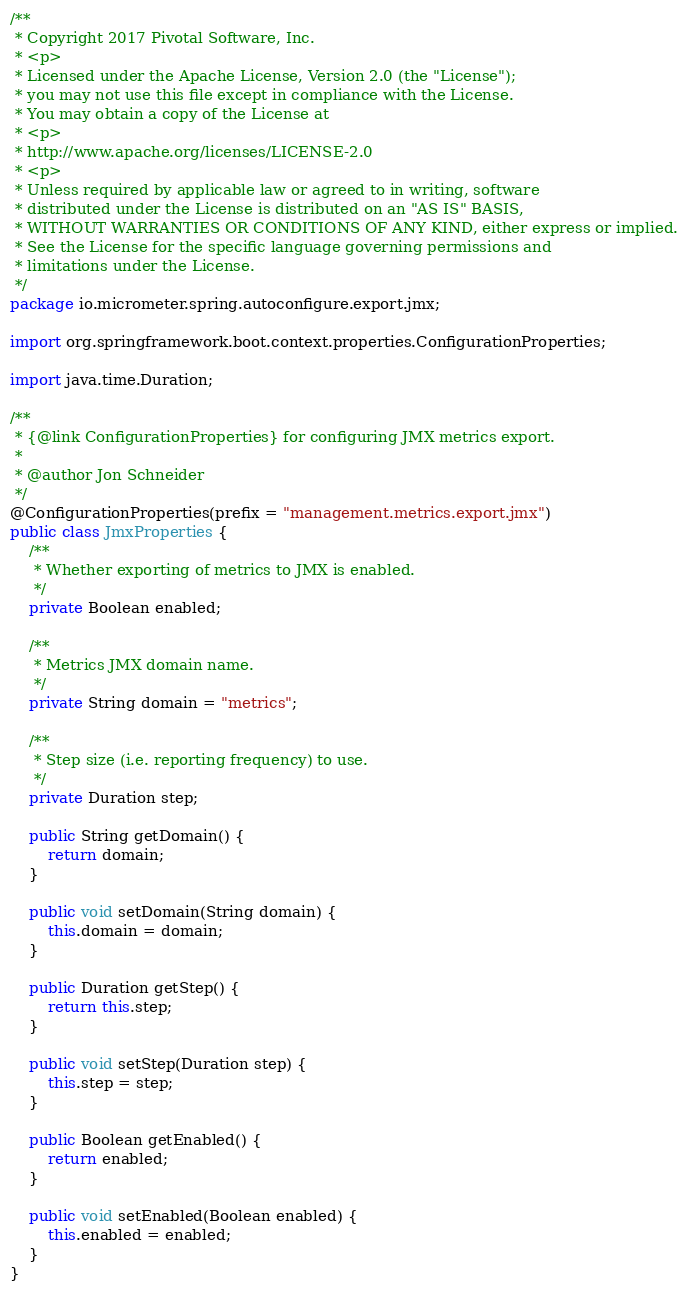Convert code to text. <code><loc_0><loc_0><loc_500><loc_500><_Java_>/**
 * Copyright 2017 Pivotal Software, Inc.
 * <p>
 * Licensed under the Apache License, Version 2.0 (the "License");
 * you may not use this file except in compliance with the License.
 * You may obtain a copy of the License at
 * <p>
 * http://www.apache.org/licenses/LICENSE-2.0
 * <p>
 * Unless required by applicable law or agreed to in writing, software
 * distributed under the License is distributed on an "AS IS" BASIS,
 * WITHOUT WARRANTIES OR CONDITIONS OF ANY KIND, either express or implied.
 * See the License for the specific language governing permissions and
 * limitations under the License.
 */
package io.micrometer.spring.autoconfigure.export.jmx;

import org.springframework.boot.context.properties.ConfigurationProperties;

import java.time.Duration;

/**
 * {@link ConfigurationProperties} for configuring JMX metrics export.
 *
 * @author Jon Schneider
 */
@ConfigurationProperties(prefix = "management.metrics.export.jmx")
public class JmxProperties {
    /**
     * Whether exporting of metrics to JMX is enabled.
     */
    private Boolean enabled;

    /**
     * Metrics JMX domain name.
     */
    private String domain = "metrics";

    /**
     * Step size (i.e. reporting frequency) to use.
     */
    private Duration step;

    public String getDomain() {
        return domain;
    }

    public void setDomain(String domain) {
        this.domain = domain;
    }

    public Duration getStep() {
        return this.step;
    }

    public void setStep(Duration step) {
        this.step = step;
    }

    public Boolean getEnabled() {
        return enabled;
    }

    public void setEnabled(Boolean enabled) {
        this.enabled = enabled;
    }
}
</code> 